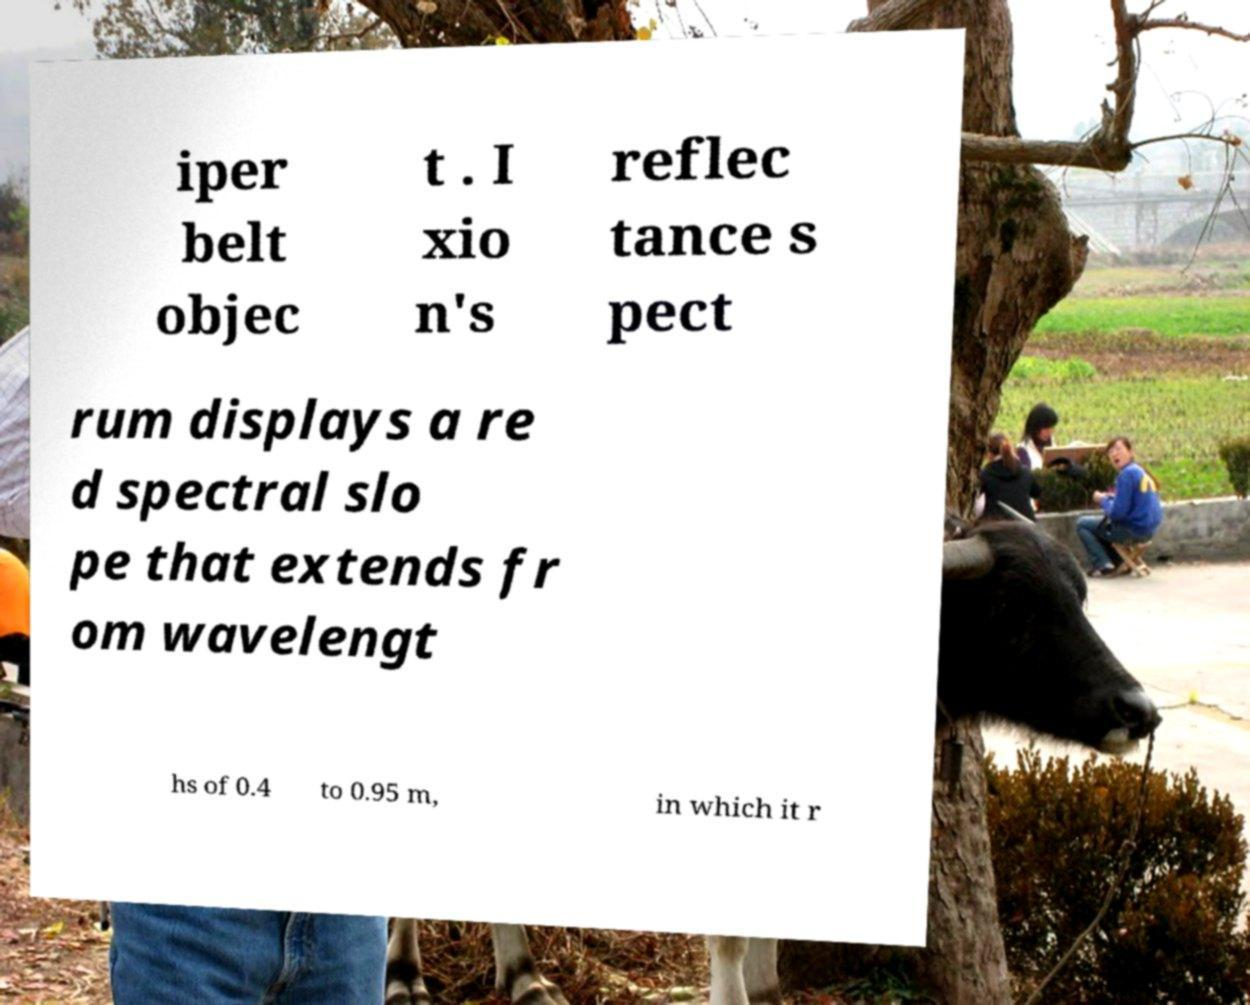Could you assist in decoding the text presented in this image and type it out clearly? iper belt objec t . I xio n's reflec tance s pect rum displays a re d spectral slo pe that extends fr om wavelengt hs of 0.4 to 0.95 m, in which it r 